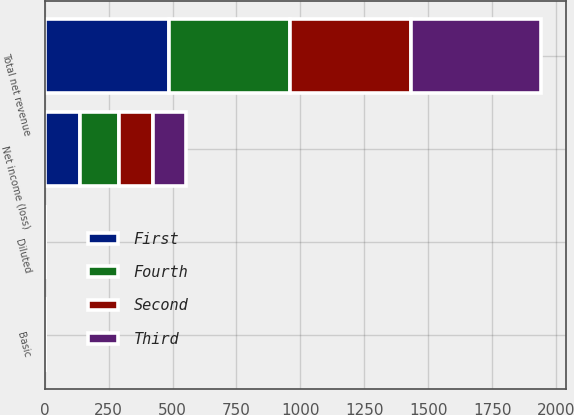<chart> <loc_0><loc_0><loc_500><loc_500><stacked_bar_chart><ecel><fcel>Total net revenue<fcel>Net income (loss)<fcel>Basic<fcel>Diluted<nl><fcel>Fourth<fcel>472<fcel>153<fcel>0.54<fcel>0.53<nl><fcel>Second<fcel>474<fcel>133<fcel>0.48<fcel>0.48<nl><fcel>First<fcel>486<fcel>139<fcel>0.51<fcel>0.51<nl><fcel>Third<fcel>509<fcel>127<fcel>0.46<fcel>0.46<nl></chart> 